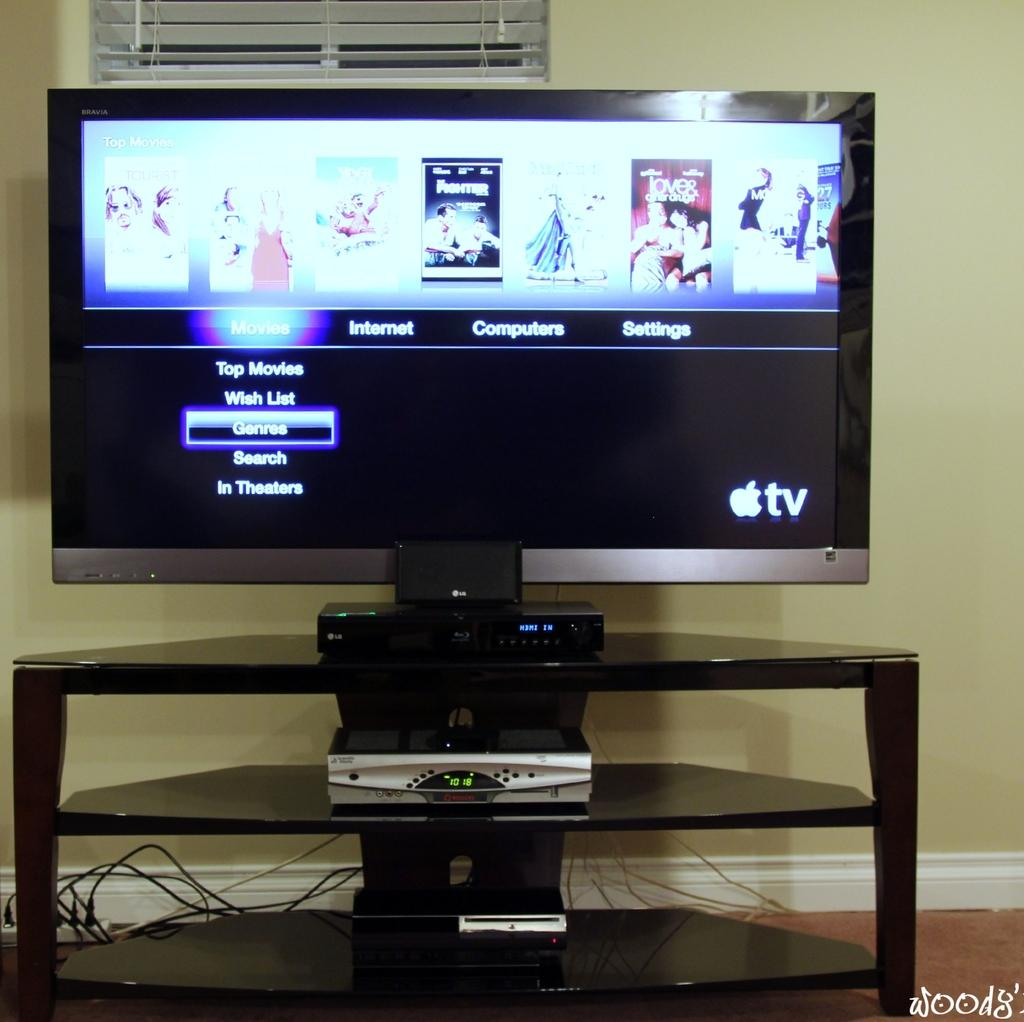<image>
Give a short and clear explanation of the subsequent image. An Apple TV menu has sections of Computers, Internet, Settings and more. 